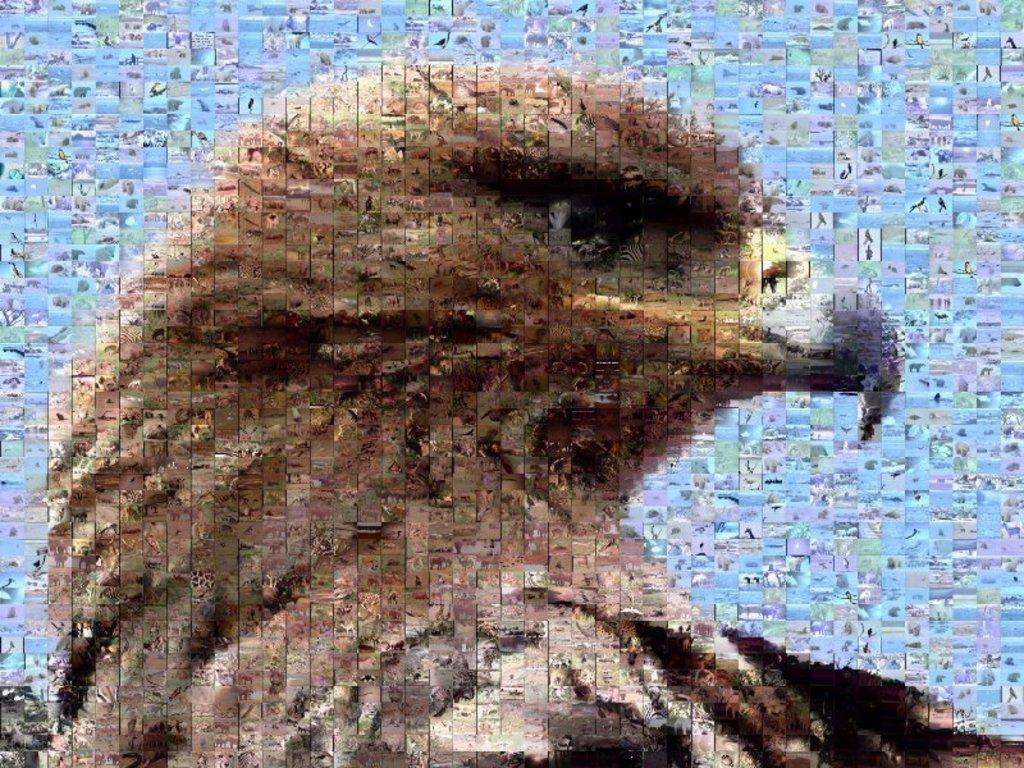What type of animal is the main subject of the image? The image features an eagle. Can you describe any modifications made to the image? The image is an edited version. What type of selection process is depicted in the image? There is no selection process depicted in the image; it features an eagle. What type of stew is being prepared in the image? There is no stew being prepared in the image; it features an eagle. 